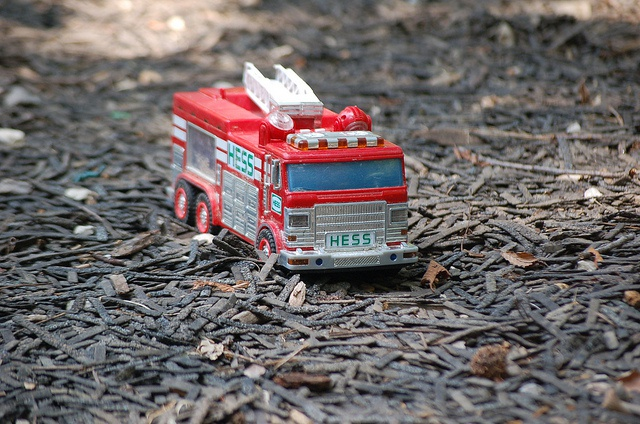Describe the objects in this image and their specific colors. I can see a truck in gray, darkgray, lightgray, and brown tones in this image. 